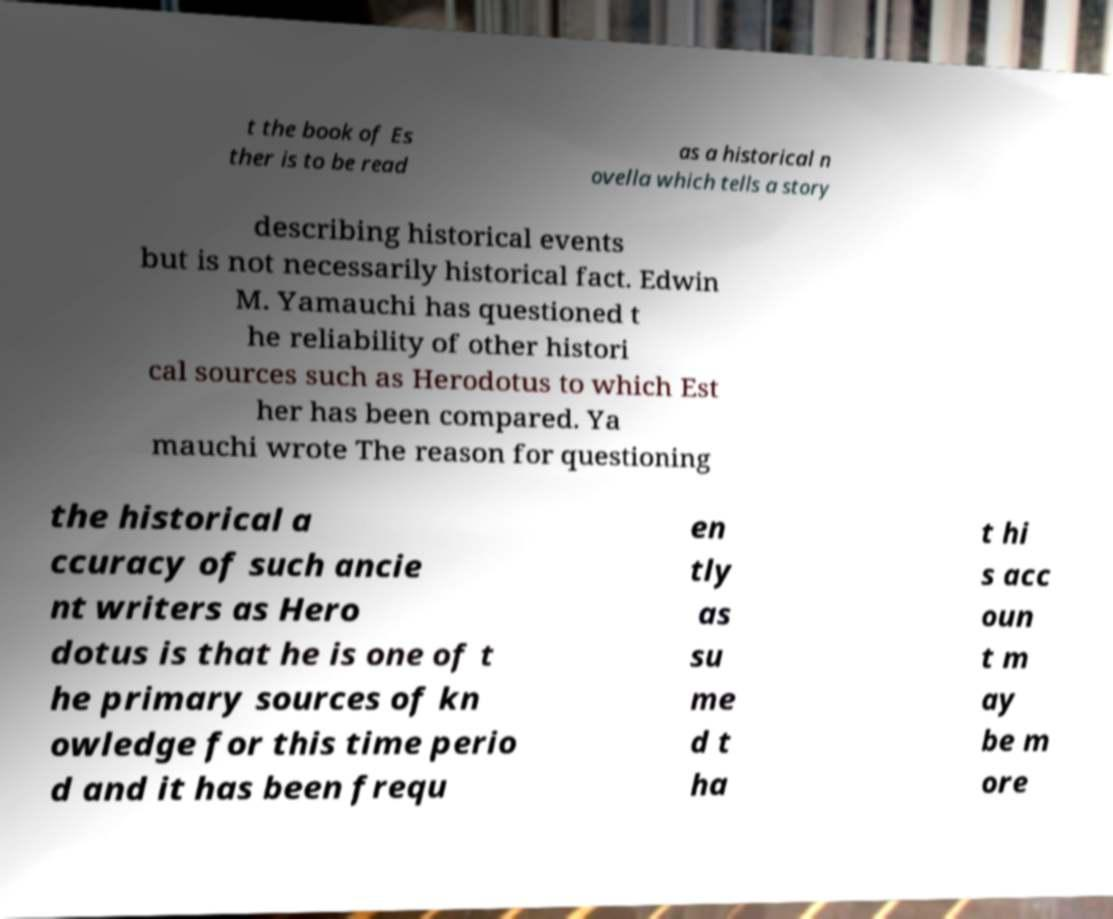Could you assist in decoding the text presented in this image and type it out clearly? t the book of Es ther is to be read as a historical n ovella which tells a story describing historical events but is not necessarily historical fact. Edwin M. Yamauchi has questioned t he reliability of other histori cal sources such as Herodotus to which Est her has been compared. Ya mauchi wrote The reason for questioning the historical a ccuracy of such ancie nt writers as Hero dotus is that he is one of t he primary sources of kn owledge for this time perio d and it has been frequ en tly as su me d t ha t hi s acc oun t m ay be m ore 